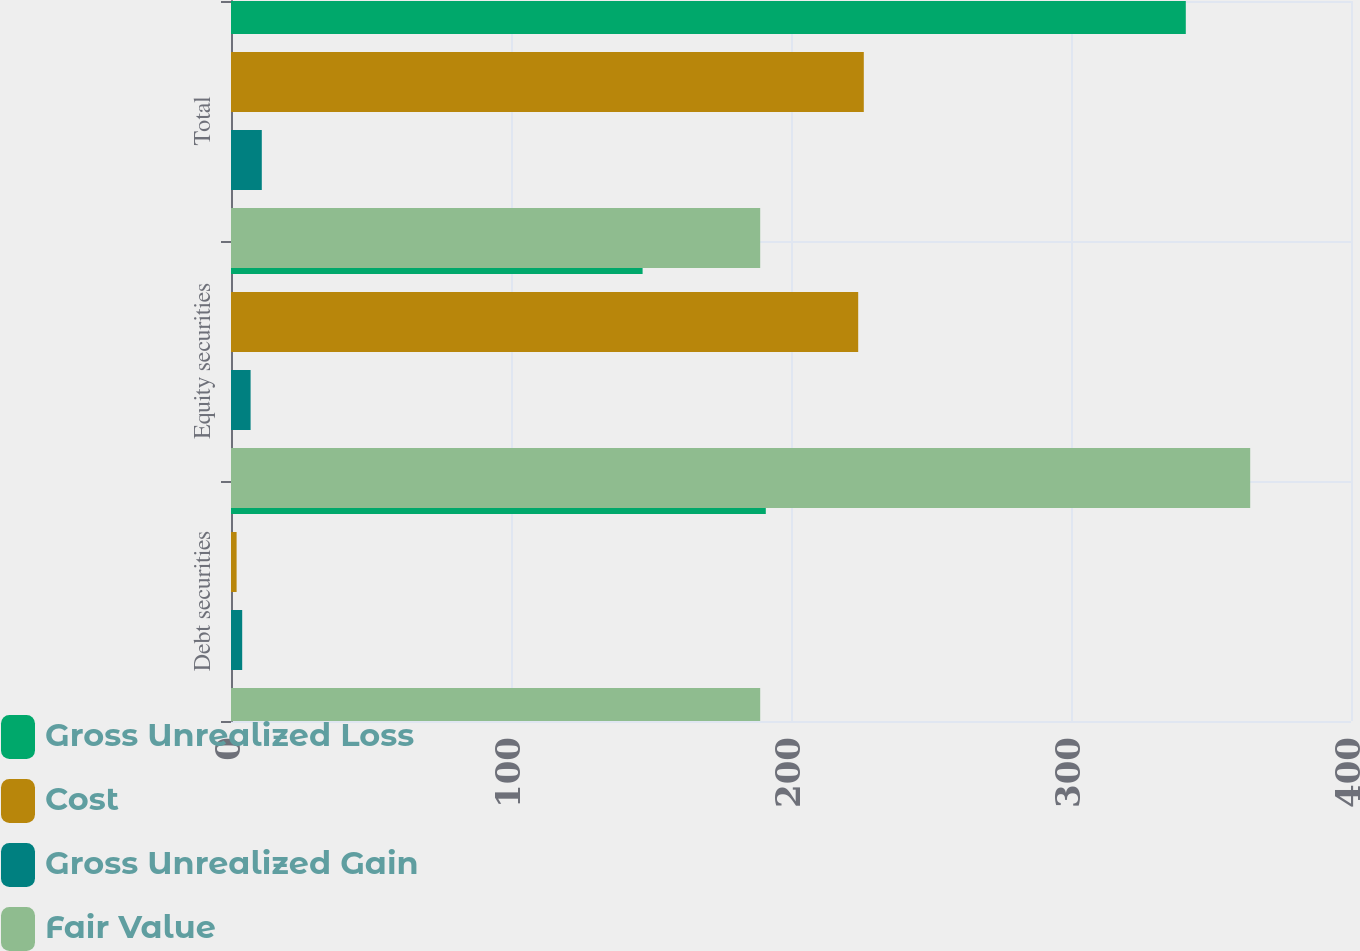Convert chart. <chart><loc_0><loc_0><loc_500><loc_500><stacked_bar_chart><ecel><fcel>Debt securities<fcel>Equity securities<fcel>Total<nl><fcel>Gross Unrealized Loss<fcel>191<fcel>147<fcel>341<nl><fcel>Cost<fcel>2<fcel>224<fcel>226<nl><fcel>Gross Unrealized Gain<fcel>4<fcel>7<fcel>11<nl><fcel>Fair Value<fcel>189<fcel>364<fcel>189<nl></chart> 